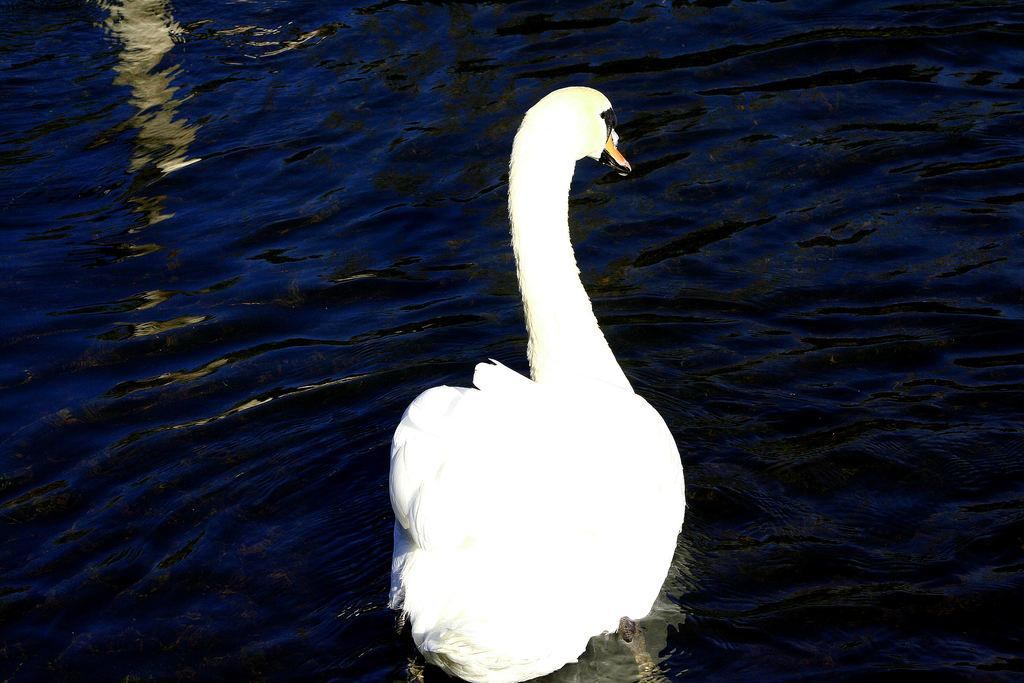What animal is present in the image? There is a swan in the image. What color is the swan? The swan is white. What is the swan doing in the image? The swan is swimming in the water. What class does the swan belong to in the image? The swan belongs to the class Aves, which is the class of birds, but this information is not directly visible in the image. 